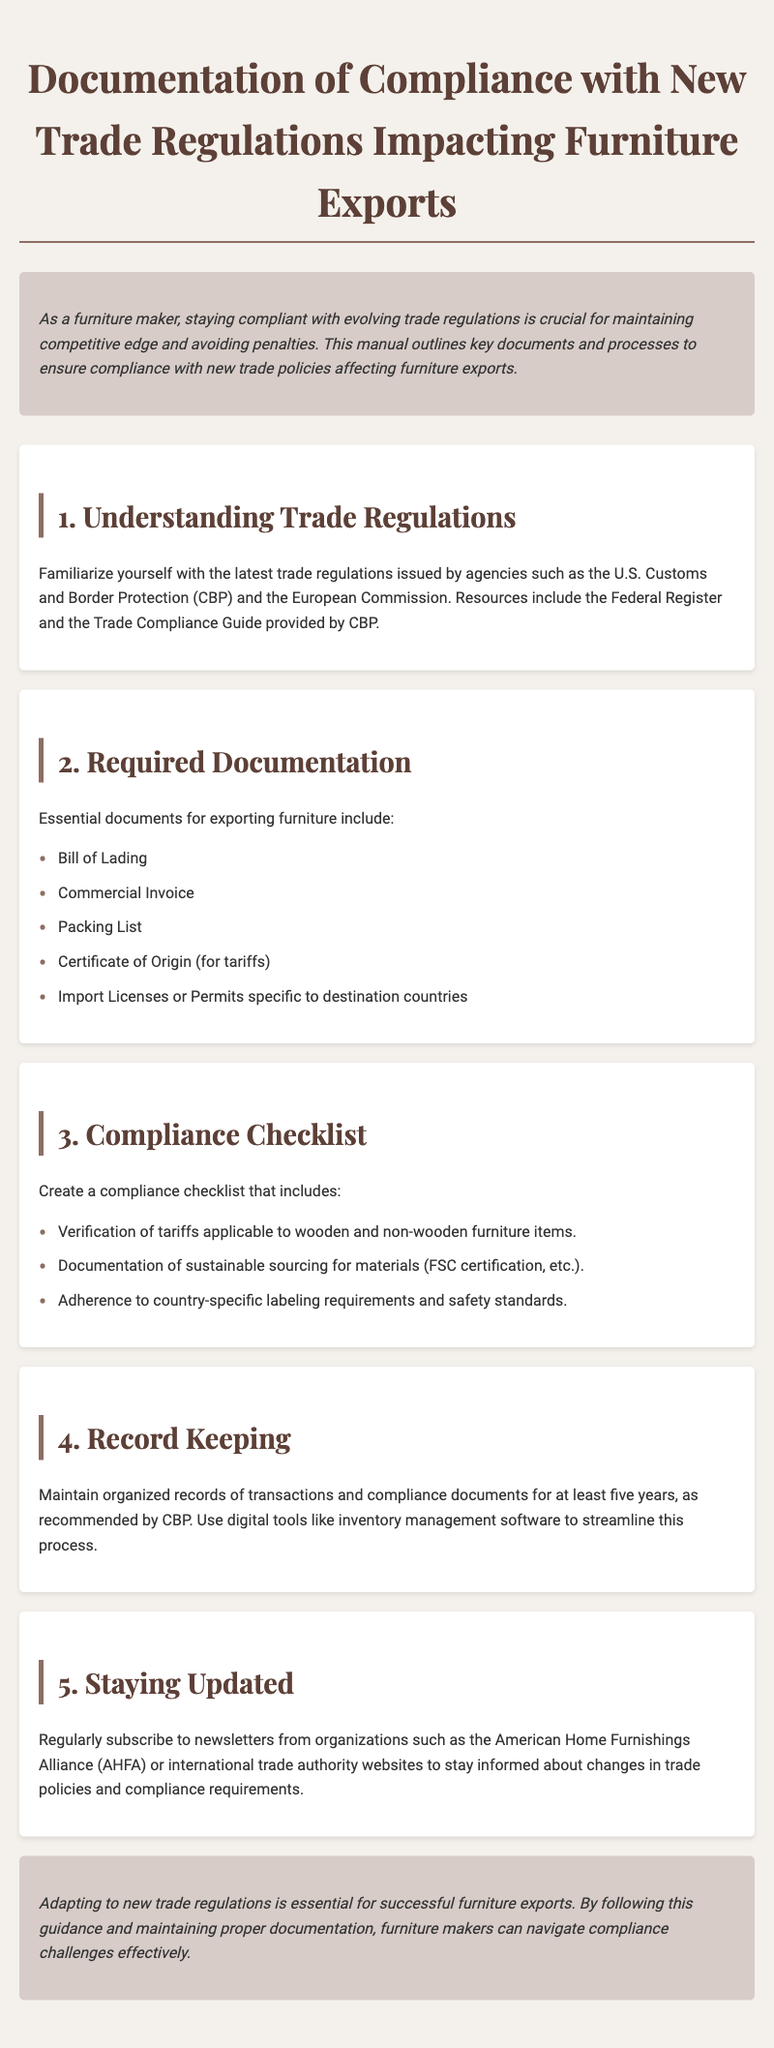What is the primary purpose of the manual? The primary purpose of the manual is to outline key documents and processes to ensure compliance with new trade policies affecting furniture exports.
Answer: To ensure compliance What organization provides the Trade Compliance Guide? The Trade Compliance Guide is provided by U.S. Customs and Border Protection (CBP).
Answer: U.S. Customs and Border Protection Which document is required for tariffs? The document required for tariffs is the Certificate of Origin.
Answer: Certificate of Origin How long should compliance documents be kept? Compliance documents should be kept for at least five years.
Answer: Five years What type of certification is mentioned for sustainable sourcing? The type of certification mentioned for sustainable sourcing is FSC certification.
Answer: FSC certification What is a recommended way to maintain organized records? A recommended way to maintain organized records is by using digital tools like inventory management software.
Answer: Digital tools Which organization should one subscribe to for trade policy updates? One should subscribe to newsletters from the American Home Furnishings Alliance (AHFA) for updates.
Answer: American Home Furnishings Alliance What is included in the compliance checklist pertaining to furniture items? The compliance checklist includes verification of tariffs applicable to wooden and non-wooden furniture items.
Answer: Verification of tariffs What is the background color of the conclusion section? The background color of the conclusion section is #d7ccc8.
Answer: #d7ccc8 